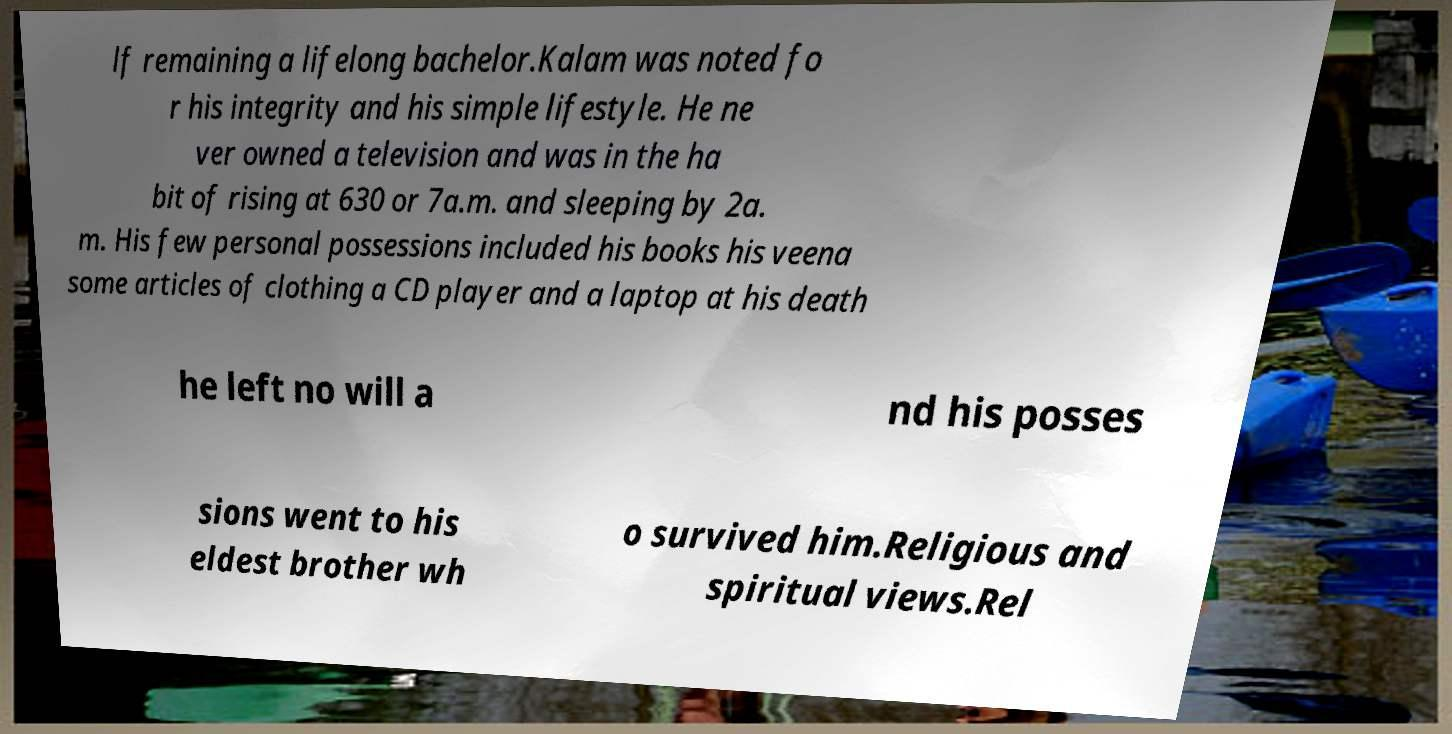There's text embedded in this image that I need extracted. Can you transcribe it verbatim? lf remaining a lifelong bachelor.Kalam was noted fo r his integrity and his simple lifestyle. He ne ver owned a television and was in the ha bit of rising at 630 or 7a.m. and sleeping by 2a. m. His few personal possessions included his books his veena some articles of clothing a CD player and a laptop at his death he left no will a nd his posses sions went to his eldest brother wh o survived him.Religious and spiritual views.Rel 